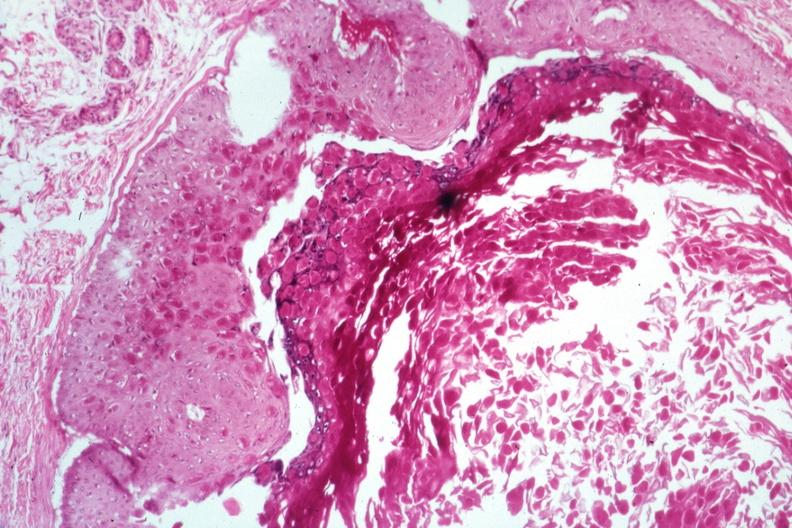s seminoma present?
Answer the question using a single word or phrase. No 